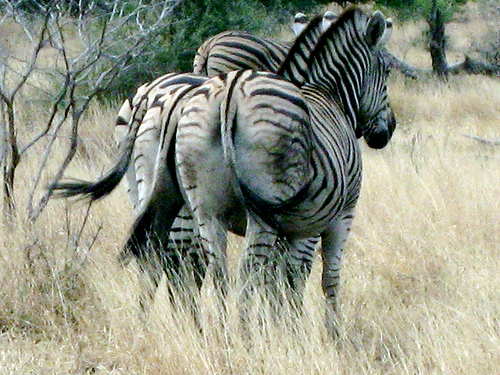Are zebras social animals? Yes, zebras are very social creatures and usually form family groups called harems, which consist of one stallion and several mares and their offspring. They can also gather into larger herds that may migrate together in search of greener pastures. How do zebras communicate with each other? Zebras communicate using an intricate system of vocalizations, body postures, and facial expressions. They make barking, snorting, and whinnying sounds to convey different messages, such as alerting others to danger or calling to stray members of the group. 